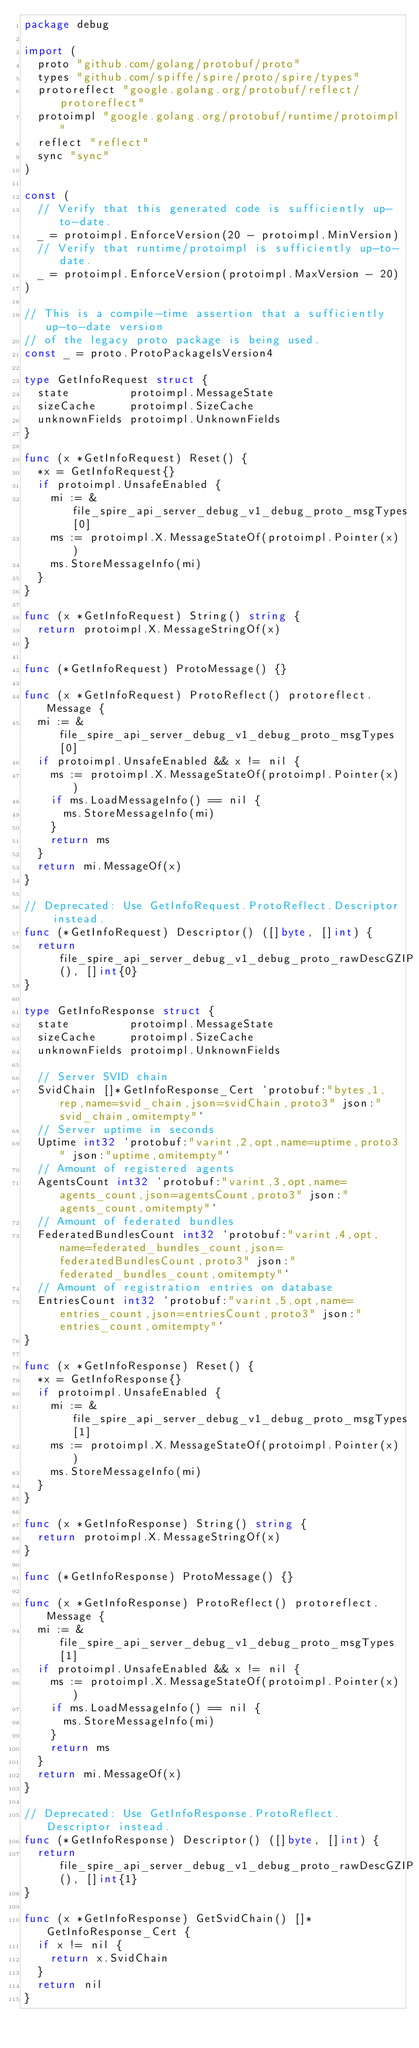Convert code to text. <code><loc_0><loc_0><loc_500><loc_500><_Go_>package debug

import (
	proto "github.com/golang/protobuf/proto"
	types "github.com/spiffe/spire/proto/spire/types"
	protoreflect "google.golang.org/protobuf/reflect/protoreflect"
	protoimpl "google.golang.org/protobuf/runtime/protoimpl"
	reflect "reflect"
	sync "sync"
)

const (
	// Verify that this generated code is sufficiently up-to-date.
	_ = protoimpl.EnforceVersion(20 - protoimpl.MinVersion)
	// Verify that runtime/protoimpl is sufficiently up-to-date.
	_ = protoimpl.EnforceVersion(protoimpl.MaxVersion - 20)
)

// This is a compile-time assertion that a sufficiently up-to-date version
// of the legacy proto package is being used.
const _ = proto.ProtoPackageIsVersion4

type GetInfoRequest struct {
	state         protoimpl.MessageState
	sizeCache     protoimpl.SizeCache
	unknownFields protoimpl.UnknownFields
}

func (x *GetInfoRequest) Reset() {
	*x = GetInfoRequest{}
	if protoimpl.UnsafeEnabled {
		mi := &file_spire_api_server_debug_v1_debug_proto_msgTypes[0]
		ms := protoimpl.X.MessageStateOf(protoimpl.Pointer(x))
		ms.StoreMessageInfo(mi)
	}
}

func (x *GetInfoRequest) String() string {
	return protoimpl.X.MessageStringOf(x)
}

func (*GetInfoRequest) ProtoMessage() {}

func (x *GetInfoRequest) ProtoReflect() protoreflect.Message {
	mi := &file_spire_api_server_debug_v1_debug_proto_msgTypes[0]
	if protoimpl.UnsafeEnabled && x != nil {
		ms := protoimpl.X.MessageStateOf(protoimpl.Pointer(x))
		if ms.LoadMessageInfo() == nil {
			ms.StoreMessageInfo(mi)
		}
		return ms
	}
	return mi.MessageOf(x)
}

// Deprecated: Use GetInfoRequest.ProtoReflect.Descriptor instead.
func (*GetInfoRequest) Descriptor() ([]byte, []int) {
	return file_spire_api_server_debug_v1_debug_proto_rawDescGZIP(), []int{0}
}

type GetInfoResponse struct {
	state         protoimpl.MessageState
	sizeCache     protoimpl.SizeCache
	unknownFields protoimpl.UnknownFields

	// Server SVID chain
	SvidChain []*GetInfoResponse_Cert `protobuf:"bytes,1,rep,name=svid_chain,json=svidChain,proto3" json:"svid_chain,omitempty"`
	// Server uptime in seconds
	Uptime int32 `protobuf:"varint,2,opt,name=uptime,proto3" json:"uptime,omitempty"`
	// Amount of registered agents
	AgentsCount int32 `protobuf:"varint,3,opt,name=agents_count,json=agentsCount,proto3" json:"agents_count,omitempty"`
	// Amount of federated bundles
	FederatedBundlesCount int32 `protobuf:"varint,4,opt,name=federated_bundles_count,json=federatedBundlesCount,proto3" json:"federated_bundles_count,omitempty"`
	// Amount of registration entries on database
	EntriesCount int32 `protobuf:"varint,5,opt,name=entries_count,json=entriesCount,proto3" json:"entries_count,omitempty"`
}

func (x *GetInfoResponse) Reset() {
	*x = GetInfoResponse{}
	if protoimpl.UnsafeEnabled {
		mi := &file_spire_api_server_debug_v1_debug_proto_msgTypes[1]
		ms := protoimpl.X.MessageStateOf(protoimpl.Pointer(x))
		ms.StoreMessageInfo(mi)
	}
}

func (x *GetInfoResponse) String() string {
	return protoimpl.X.MessageStringOf(x)
}

func (*GetInfoResponse) ProtoMessage() {}

func (x *GetInfoResponse) ProtoReflect() protoreflect.Message {
	mi := &file_spire_api_server_debug_v1_debug_proto_msgTypes[1]
	if protoimpl.UnsafeEnabled && x != nil {
		ms := protoimpl.X.MessageStateOf(protoimpl.Pointer(x))
		if ms.LoadMessageInfo() == nil {
			ms.StoreMessageInfo(mi)
		}
		return ms
	}
	return mi.MessageOf(x)
}

// Deprecated: Use GetInfoResponse.ProtoReflect.Descriptor instead.
func (*GetInfoResponse) Descriptor() ([]byte, []int) {
	return file_spire_api_server_debug_v1_debug_proto_rawDescGZIP(), []int{1}
}

func (x *GetInfoResponse) GetSvidChain() []*GetInfoResponse_Cert {
	if x != nil {
		return x.SvidChain
	}
	return nil
}
</code> 